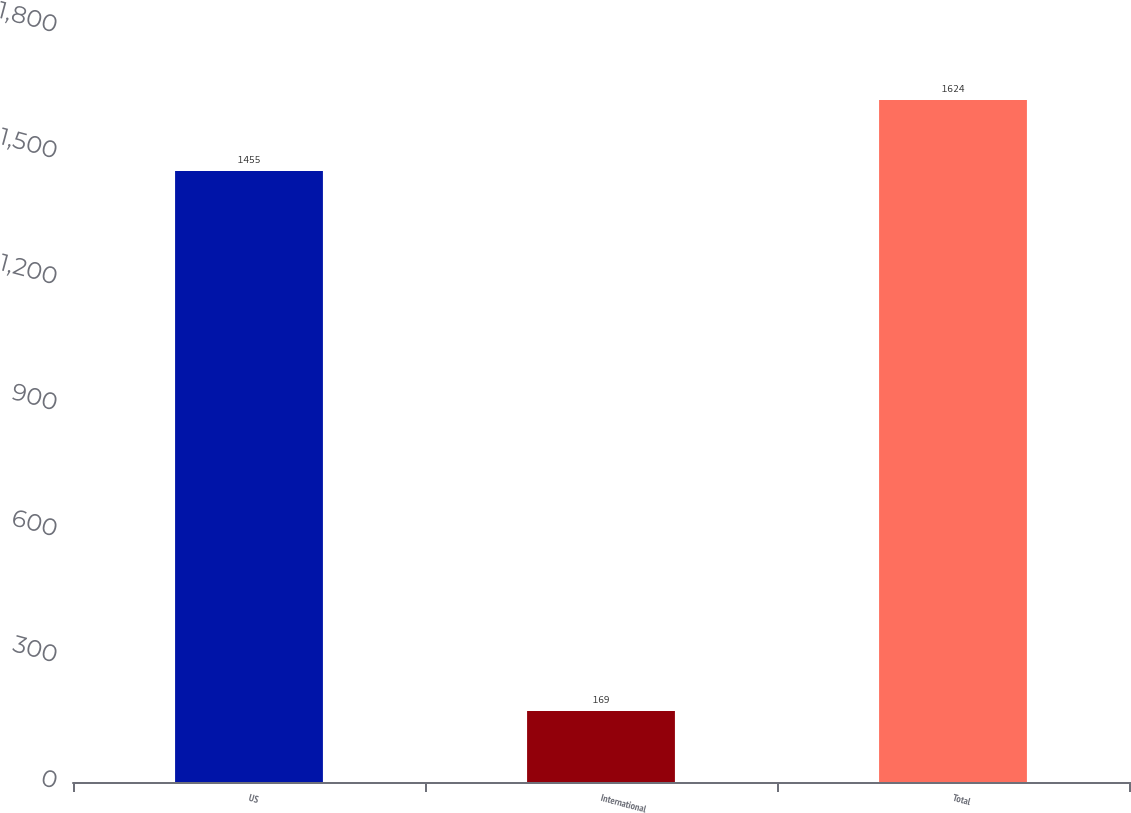Convert chart to OTSL. <chart><loc_0><loc_0><loc_500><loc_500><bar_chart><fcel>US<fcel>International<fcel>Total<nl><fcel>1455<fcel>169<fcel>1624<nl></chart> 